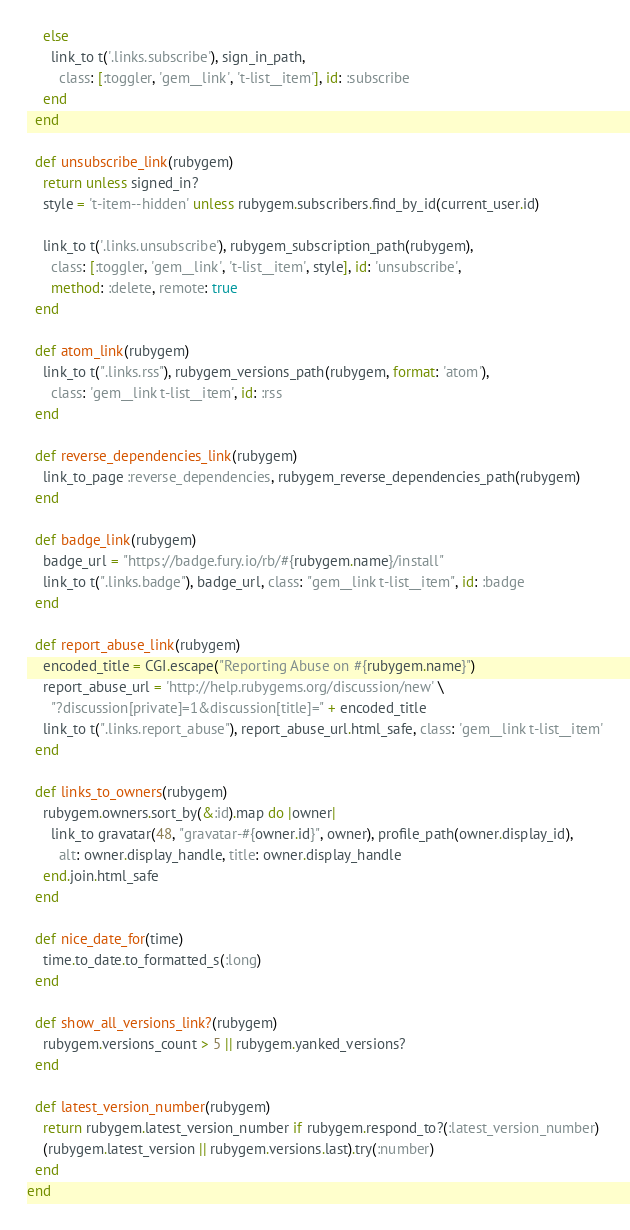<code> <loc_0><loc_0><loc_500><loc_500><_Ruby_>    else
      link_to t('.links.subscribe'), sign_in_path,
        class: [:toggler, 'gem__link', 't-list__item'], id: :subscribe
    end
  end

  def unsubscribe_link(rubygem)
    return unless signed_in?
    style = 't-item--hidden' unless rubygem.subscribers.find_by_id(current_user.id)

    link_to t('.links.unsubscribe'), rubygem_subscription_path(rubygem),
      class: [:toggler, 'gem__link', 't-list__item', style], id: 'unsubscribe',
      method: :delete, remote: true
  end

  def atom_link(rubygem)
    link_to t(".links.rss"), rubygem_versions_path(rubygem, format: 'atom'),
      class: 'gem__link t-list__item', id: :rss
  end

  def reverse_dependencies_link(rubygem)
    link_to_page :reverse_dependencies, rubygem_reverse_dependencies_path(rubygem)
  end

  def badge_link(rubygem)
    badge_url = "https://badge.fury.io/rb/#{rubygem.name}/install"
    link_to t(".links.badge"), badge_url, class: "gem__link t-list__item", id: :badge
  end

  def report_abuse_link(rubygem)
    encoded_title = CGI.escape("Reporting Abuse on #{rubygem.name}")
    report_abuse_url = 'http://help.rubygems.org/discussion/new' \
      "?discussion[private]=1&discussion[title]=" + encoded_title
    link_to t(".links.report_abuse"), report_abuse_url.html_safe, class: 'gem__link t-list__item'
  end

  def links_to_owners(rubygem)
    rubygem.owners.sort_by(&:id).map do |owner|
      link_to gravatar(48, "gravatar-#{owner.id}", owner), profile_path(owner.display_id),
        alt: owner.display_handle, title: owner.display_handle
    end.join.html_safe
  end

  def nice_date_for(time)
    time.to_date.to_formatted_s(:long)
  end

  def show_all_versions_link?(rubygem)
    rubygem.versions_count > 5 || rubygem.yanked_versions?
  end

  def latest_version_number(rubygem)
    return rubygem.latest_version_number if rubygem.respond_to?(:latest_version_number)
    (rubygem.latest_version || rubygem.versions.last).try(:number)
  end
end
</code> 